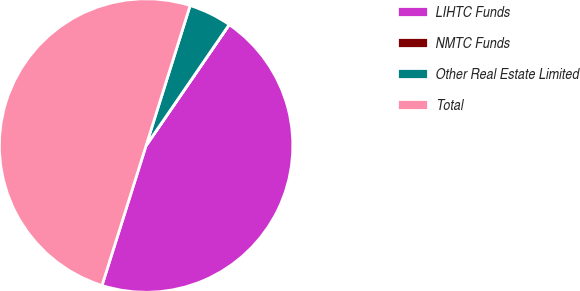Convert chart to OTSL. <chart><loc_0><loc_0><loc_500><loc_500><pie_chart><fcel>LIHTC Funds<fcel>NMTC Funds<fcel>Other Real Estate Limited<fcel>Total<nl><fcel>45.27%<fcel>0.01%<fcel>4.73%<fcel>49.99%<nl></chart> 